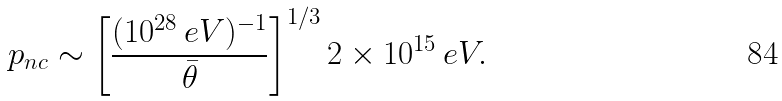Convert formula to latex. <formula><loc_0><loc_0><loc_500><loc_500>p _ { n c } \sim \left [ \frac { ( 1 0 ^ { 2 8 } \, e V ) ^ { - 1 } } { \bar { \theta } } \right ] ^ { 1 / 3 } 2 \times 1 0 ^ { 1 5 } \, e V .</formula> 